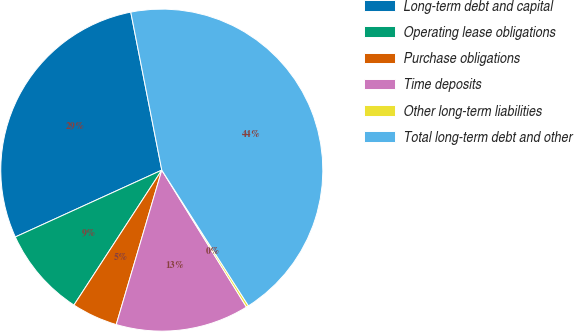Convert chart. <chart><loc_0><loc_0><loc_500><loc_500><pie_chart><fcel>Long-term debt and capital<fcel>Operating lease obligations<fcel>Purchase obligations<fcel>Time deposits<fcel>Other long-term liabilities<fcel>Total long-term debt and other<nl><fcel>28.73%<fcel>9.0%<fcel>4.62%<fcel>13.38%<fcel>0.23%<fcel>44.05%<nl></chart> 